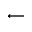<formula> <loc_0><loc_0><loc_500><loc_500>\longleftarrow</formula> 